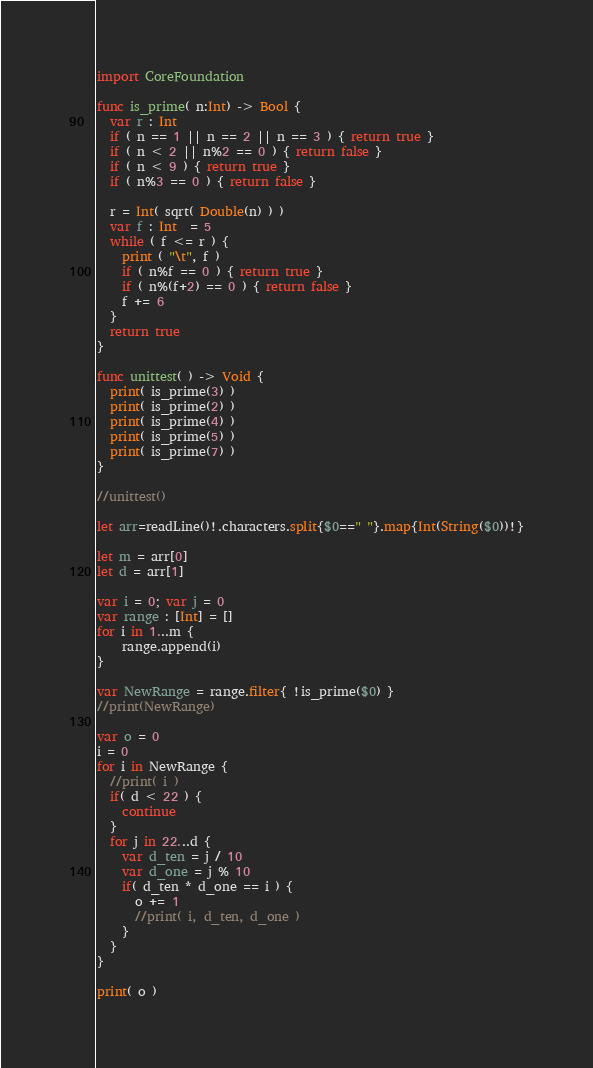<code> <loc_0><loc_0><loc_500><loc_500><_Swift_>import CoreFoundation

func is_prime( n:Int) -> Bool {
  var r : Int
  if ( n == 1 || n == 2 || n == 3 ) { return true }
  if ( n < 2 || n%2 == 0 ) { return false }
  if ( n < 9 ) { return true }
  if ( n%3 == 0 ) { return false }

  r = Int( sqrt( Double(n) ) )
  var f : Int  = 5
  while ( f <= r ) {
    print ( "\t", f )
    if ( n%f == 0 ) { return true }
    if ( n%(f+2) == 0 ) { return false }
    f += 6
  }
  return true
}

func unittest( ) -> Void {
  print( is_prime(3) )
  print( is_prime(2) )
  print( is_prime(4) )
  print( is_prime(5) )
  print( is_prime(7) )
}

//unittest()

let arr=readLine()!.characters.split{$0==" "}.map{Int(String($0))!}

let m = arr[0]
let d = arr[1]

var i = 0; var j = 0
var range : [Int] = []
for i in 1...m {
	range.append(i)
}

var NewRange = range.filter{ !is_prime($0) } 
//print(NewRange)

var o = 0
i = 0
for i in NewRange {
  //print( i )
  if( d < 22 ) {
    continue
  }
  for j in 22...d {
    var d_ten = j / 10
    var d_one = j % 10
    if( d_ten * d_one == i ) {
      o += 1
      //print( i, d_ten, d_one )
    }
  }
}

print( o )</code> 